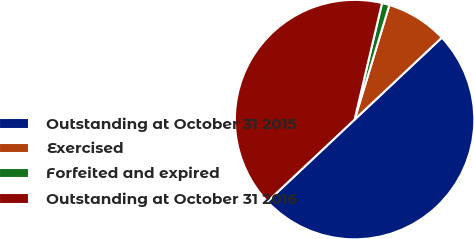<chart> <loc_0><loc_0><loc_500><loc_500><pie_chart><fcel>Outstanding at October 31 2015<fcel>Exercised<fcel>Forfeited and expired<fcel>Outstanding at October 31 2016<nl><fcel>50.0%<fcel>8.3%<fcel>1.01%<fcel>40.7%<nl></chart> 